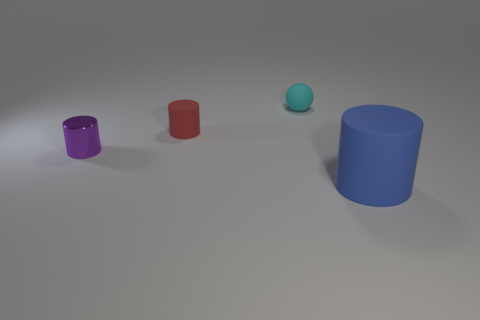Subtract all matte cylinders. How many cylinders are left? 1 Subtract all blue cylinders. How many cylinders are left? 2 Subtract all balls. How many objects are left? 3 Add 2 gray rubber balls. How many objects exist? 6 Subtract 0 green cubes. How many objects are left? 4 Subtract 1 spheres. How many spheres are left? 0 Subtract all red spheres. Subtract all brown cylinders. How many spheres are left? 1 Subtract all brown cubes. How many purple cylinders are left? 1 Subtract all tiny spheres. Subtract all red rubber objects. How many objects are left? 2 Add 4 big rubber cylinders. How many big rubber cylinders are left? 5 